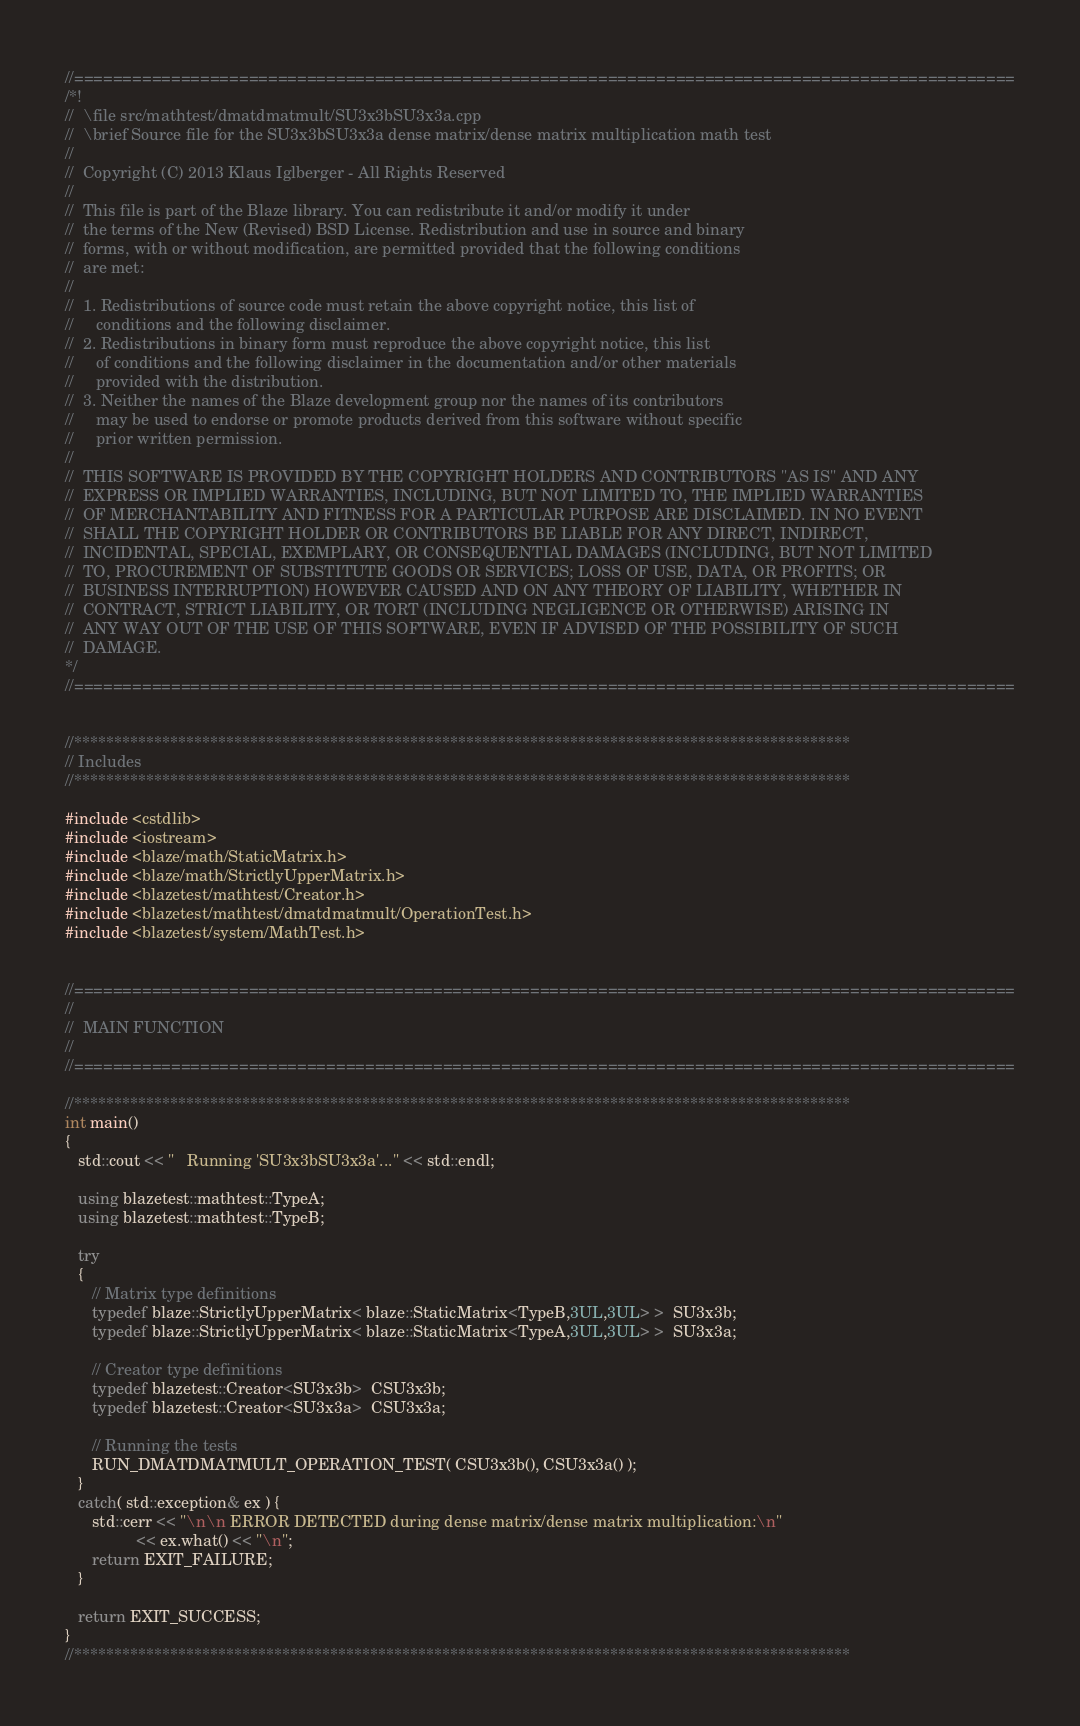<code> <loc_0><loc_0><loc_500><loc_500><_C++_>//=================================================================================================
/*!
//  \file src/mathtest/dmatdmatmult/SU3x3bSU3x3a.cpp
//  \brief Source file for the SU3x3bSU3x3a dense matrix/dense matrix multiplication math test
//
//  Copyright (C) 2013 Klaus Iglberger - All Rights Reserved
//
//  This file is part of the Blaze library. You can redistribute it and/or modify it under
//  the terms of the New (Revised) BSD License. Redistribution and use in source and binary
//  forms, with or without modification, are permitted provided that the following conditions
//  are met:
//
//  1. Redistributions of source code must retain the above copyright notice, this list of
//     conditions and the following disclaimer.
//  2. Redistributions in binary form must reproduce the above copyright notice, this list
//     of conditions and the following disclaimer in the documentation and/or other materials
//     provided with the distribution.
//  3. Neither the names of the Blaze development group nor the names of its contributors
//     may be used to endorse or promote products derived from this software without specific
//     prior written permission.
//
//  THIS SOFTWARE IS PROVIDED BY THE COPYRIGHT HOLDERS AND CONTRIBUTORS "AS IS" AND ANY
//  EXPRESS OR IMPLIED WARRANTIES, INCLUDING, BUT NOT LIMITED TO, THE IMPLIED WARRANTIES
//  OF MERCHANTABILITY AND FITNESS FOR A PARTICULAR PURPOSE ARE DISCLAIMED. IN NO EVENT
//  SHALL THE COPYRIGHT HOLDER OR CONTRIBUTORS BE LIABLE FOR ANY DIRECT, INDIRECT,
//  INCIDENTAL, SPECIAL, EXEMPLARY, OR CONSEQUENTIAL DAMAGES (INCLUDING, BUT NOT LIMITED
//  TO, PROCUREMENT OF SUBSTITUTE GOODS OR SERVICES; LOSS OF USE, DATA, OR PROFITS; OR
//  BUSINESS INTERRUPTION) HOWEVER CAUSED AND ON ANY THEORY OF LIABILITY, WHETHER IN
//  CONTRACT, STRICT LIABILITY, OR TORT (INCLUDING NEGLIGENCE OR OTHERWISE) ARISING IN
//  ANY WAY OUT OF THE USE OF THIS SOFTWARE, EVEN IF ADVISED OF THE POSSIBILITY OF SUCH
//  DAMAGE.
*/
//=================================================================================================


//*************************************************************************************************
// Includes
//*************************************************************************************************

#include <cstdlib>
#include <iostream>
#include <blaze/math/StaticMatrix.h>
#include <blaze/math/StrictlyUpperMatrix.h>
#include <blazetest/mathtest/Creator.h>
#include <blazetest/mathtest/dmatdmatmult/OperationTest.h>
#include <blazetest/system/MathTest.h>


//=================================================================================================
//
//  MAIN FUNCTION
//
//=================================================================================================

//*************************************************************************************************
int main()
{
   std::cout << "   Running 'SU3x3bSU3x3a'..." << std::endl;

   using blazetest::mathtest::TypeA;
   using blazetest::mathtest::TypeB;

   try
   {
      // Matrix type definitions
      typedef blaze::StrictlyUpperMatrix< blaze::StaticMatrix<TypeB,3UL,3UL> >  SU3x3b;
      typedef blaze::StrictlyUpperMatrix< blaze::StaticMatrix<TypeA,3UL,3UL> >  SU3x3a;

      // Creator type definitions
      typedef blazetest::Creator<SU3x3b>  CSU3x3b;
      typedef blazetest::Creator<SU3x3a>  CSU3x3a;

      // Running the tests
      RUN_DMATDMATMULT_OPERATION_TEST( CSU3x3b(), CSU3x3a() );
   }
   catch( std::exception& ex ) {
      std::cerr << "\n\n ERROR DETECTED during dense matrix/dense matrix multiplication:\n"
                << ex.what() << "\n";
      return EXIT_FAILURE;
   }

   return EXIT_SUCCESS;
}
//*************************************************************************************************
</code> 